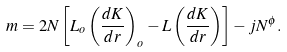<formula> <loc_0><loc_0><loc_500><loc_500>m = 2 N \left [ L _ { o } \left ( \frac { d K } { d r } \right ) _ { o } - L \left ( \frac { d K } { d r } \right ) \right ] - j N ^ { \phi } .</formula> 